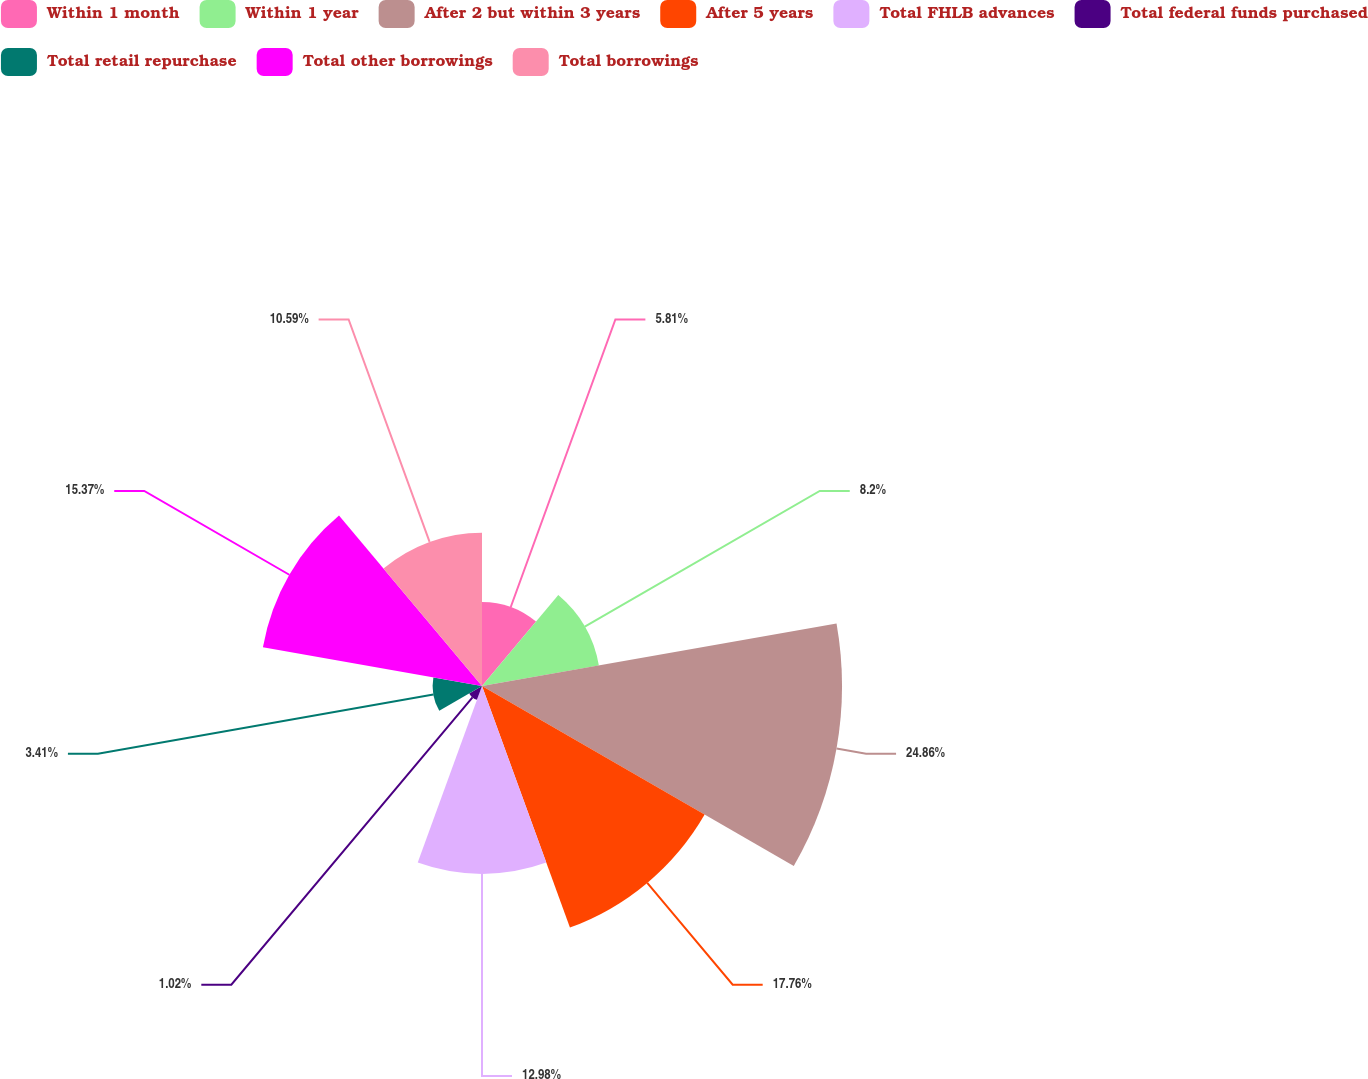Convert chart to OTSL. <chart><loc_0><loc_0><loc_500><loc_500><pie_chart><fcel>Within 1 month<fcel>Within 1 year<fcel>After 2 but within 3 years<fcel>After 5 years<fcel>Total FHLB advances<fcel>Total federal funds purchased<fcel>Total retail repurchase<fcel>Total other borrowings<fcel>Total borrowings<nl><fcel>5.81%<fcel>8.2%<fcel>24.87%<fcel>17.76%<fcel>12.98%<fcel>1.02%<fcel>3.41%<fcel>15.37%<fcel>10.59%<nl></chart> 